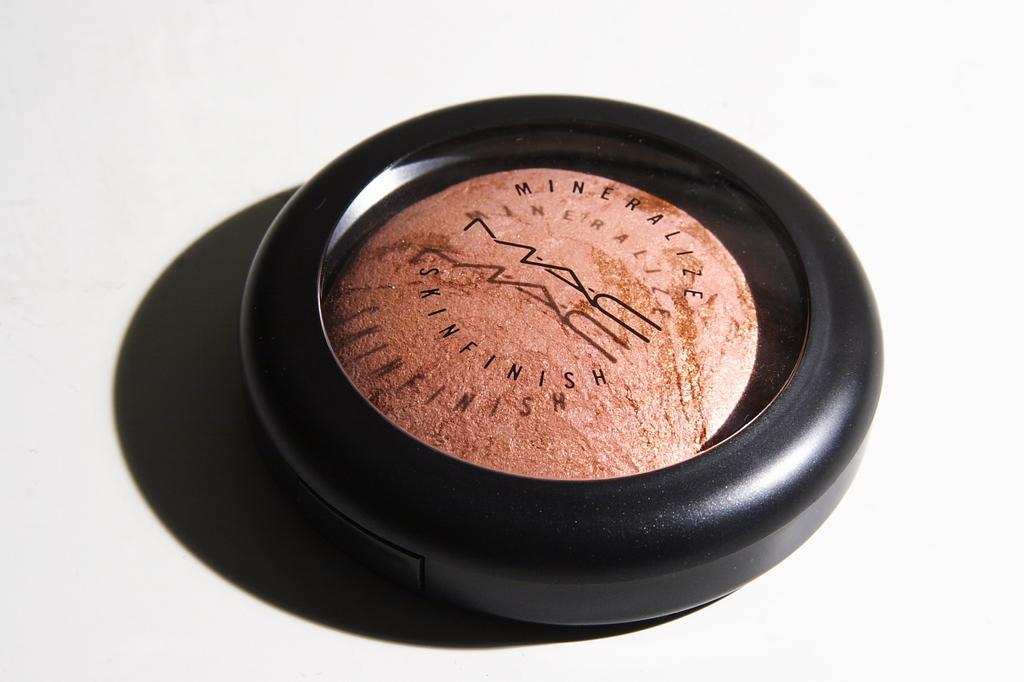<image>
Relay a brief, clear account of the picture shown. a black object with a brown one that says Mineralize on it 